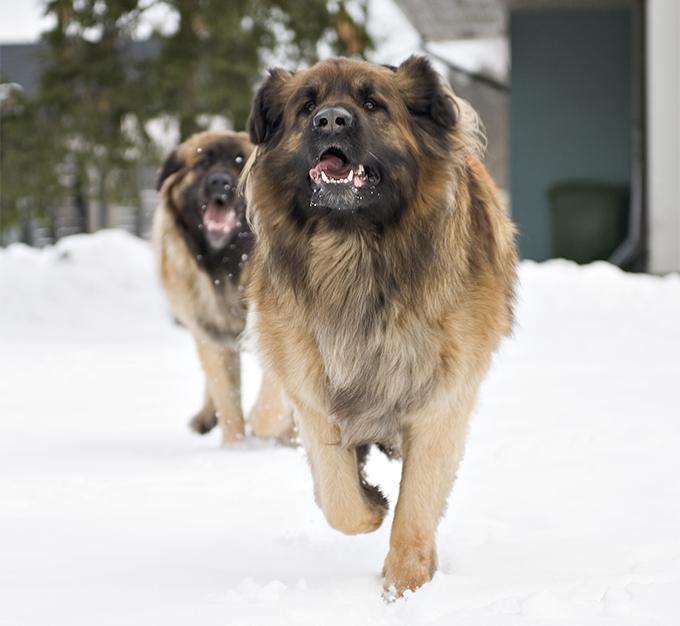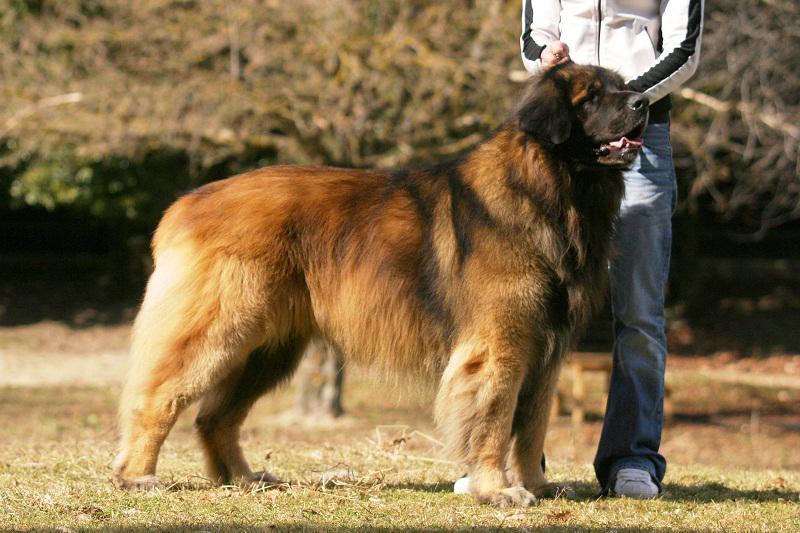The first image is the image on the left, the second image is the image on the right. Examine the images to the left and right. Is the description "The left image contains exactly two dogs." accurate? Answer yes or no. Yes. The first image is the image on the left, the second image is the image on the right. Given the left and right images, does the statement "A person is standing by a large dog in one image." hold true? Answer yes or no. Yes. The first image is the image on the left, the second image is the image on the right. Analyze the images presented: Is the assertion "A female with bent knees is on the left of a big dog, which is the only dog in the image." valid? Answer yes or no. No. 